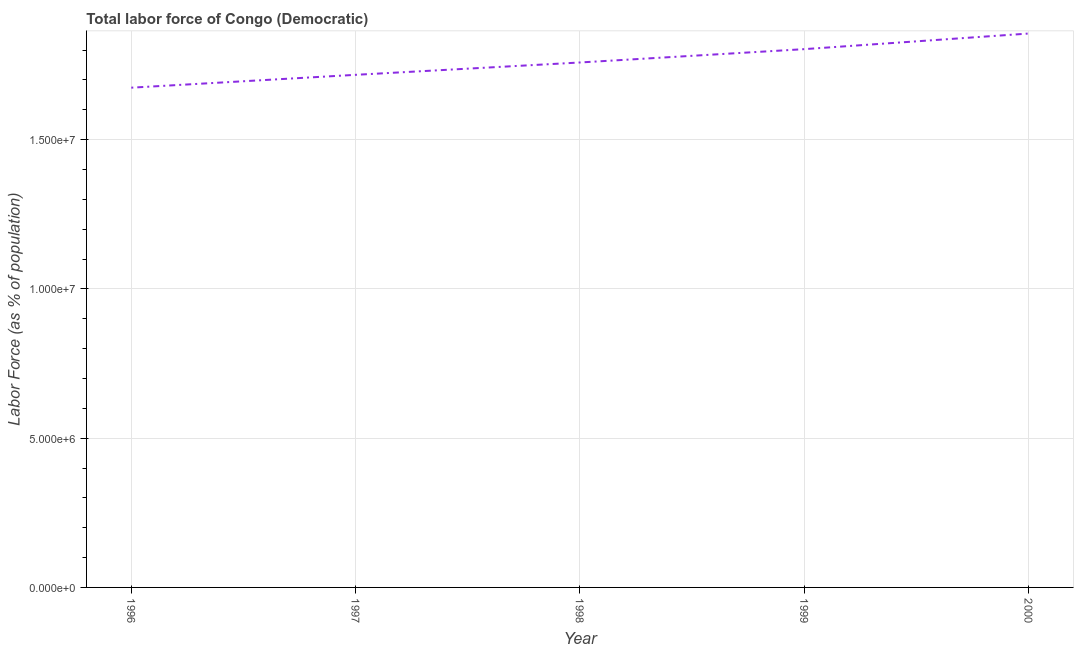What is the total labor force in 1996?
Ensure brevity in your answer.  1.67e+07. Across all years, what is the maximum total labor force?
Ensure brevity in your answer.  1.86e+07. Across all years, what is the minimum total labor force?
Give a very brief answer. 1.67e+07. In which year was the total labor force maximum?
Offer a terse response. 2000. What is the sum of the total labor force?
Keep it short and to the point. 8.81e+07. What is the difference between the total labor force in 1999 and 2000?
Your response must be concise. -5.23e+05. What is the average total labor force per year?
Give a very brief answer. 1.76e+07. What is the median total labor force?
Make the answer very short. 1.76e+07. In how many years, is the total labor force greater than 15000000 %?
Provide a short and direct response. 5. Do a majority of the years between 1998 and 1996 (inclusive) have total labor force greater than 11000000 %?
Give a very brief answer. No. What is the ratio of the total labor force in 1998 to that in 1999?
Give a very brief answer. 0.98. Is the difference between the total labor force in 1997 and 2000 greater than the difference between any two years?
Offer a very short reply. No. What is the difference between the highest and the second highest total labor force?
Your response must be concise. 5.23e+05. What is the difference between the highest and the lowest total labor force?
Offer a very short reply. 1.81e+06. Does the total labor force monotonically increase over the years?
Your response must be concise. Yes. How many years are there in the graph?
Your response must be concise. 5. What is the difference between two consecutive major ticks on the Y-axis?
Offer a terse response. 5.00e+06. Are the values on the major ticks of Y-axis written in scientific E-notation?
Keep it short and to the point. Yes. What is the title of the graph?
Your response must be concise. Total labor force of Congo (Democratic). What is the label or title of the X-axis?
Your answer should be compact. Year. What is the label or title of the Y-axis?
Your response must be concise. Labor Force (as % of population). What is the Labor Force (as % of population) of 1996?
Ensure brevity in your answer.  1.67e+07. What is the Labor Force (as % of population) of 1997?
Offer a very short reply. 1.72e+07. What is the Labor Force (as % of population) of 1998?
Keep it short and to the point. 1.76e+07. What is the Labor Force (as % of population) of 1999?
Offer a very short reply. 1.80e+07. What is the Labor Force (as % of population) of 2000?
Offer a terse response. 1.86e+07. What is the difference between the Labor Force (as % of population) in 1996 and 1997?
Provide a succinct answer. -4.31e+05. What is the difference between the Labor Force (as % of population) in 1996 and 1998?
Your response must be concise. -8.44e+05. What is the difference between the Labor Force (as % of population) in 1996 and 1999?
Provide a short and direct response. -1.29e+06. What is the difference between the Labor Force (as % of population) in 1996 and 2000?
Keep it short and to the point. -1.81e+06. What is the difference between the Labor Force (as % of population) in 1997 and 1998?
Provide a short and direct response. -4.13e+05. What is the difference between the Labor Force (as % of population) in 1997 and 1999?
Your answer should be very brief. -8.60e+05. What is the difference between the Labor Force (as % of population) in 1997 and 2000?
Ensure brevity in your answer.  -1.38e+06. What is the difference between the Labor Force (as % of population) in 1998 and 1999?
Your answer should be compact. -4.47e+05. What is the difference between the Labor Force (as % of population) in 1998 and 2000?
Your response must be concise. -9.70e+05. What is the difference between the Labor Force (as % of population) in 1999 and 2000?
Give a very brief answer. -5.23e+05. What is the ratio of the Labor Force (as % of population) in 1996 to that in 1997?
Make the answer very short. 0.97. What is the ratio of the Labor Force (as % of population) in 1996 to that in 1998?
Provide a succinct answer. 0.95. What is the ratio of the Labor Force (as % of population) in 1996 to that in 1999?
Keep it short and to the point. 0.93. What is the ratio of the Labor Force (as % of population) in 1996 to that in 2000?
Your answer should be very brief. 0.9. What is the ratio of the Labor Force (as % of population) in 1997 to that in 1998?
Offer a very short reply. 0.98. What is the ratio of the Labor Force (as % of population) in 1997 to that in 2000?
Your answer should be compact. 0.93. What is the ratio of the Labor Force (as % of population) in 1998 to that in 2000?
Offer a terse response. 0.95. What is the ratio of the Labor Force (as % of population) in 1999 to that in 2000?
Provide a short and direct response. 0.97. 